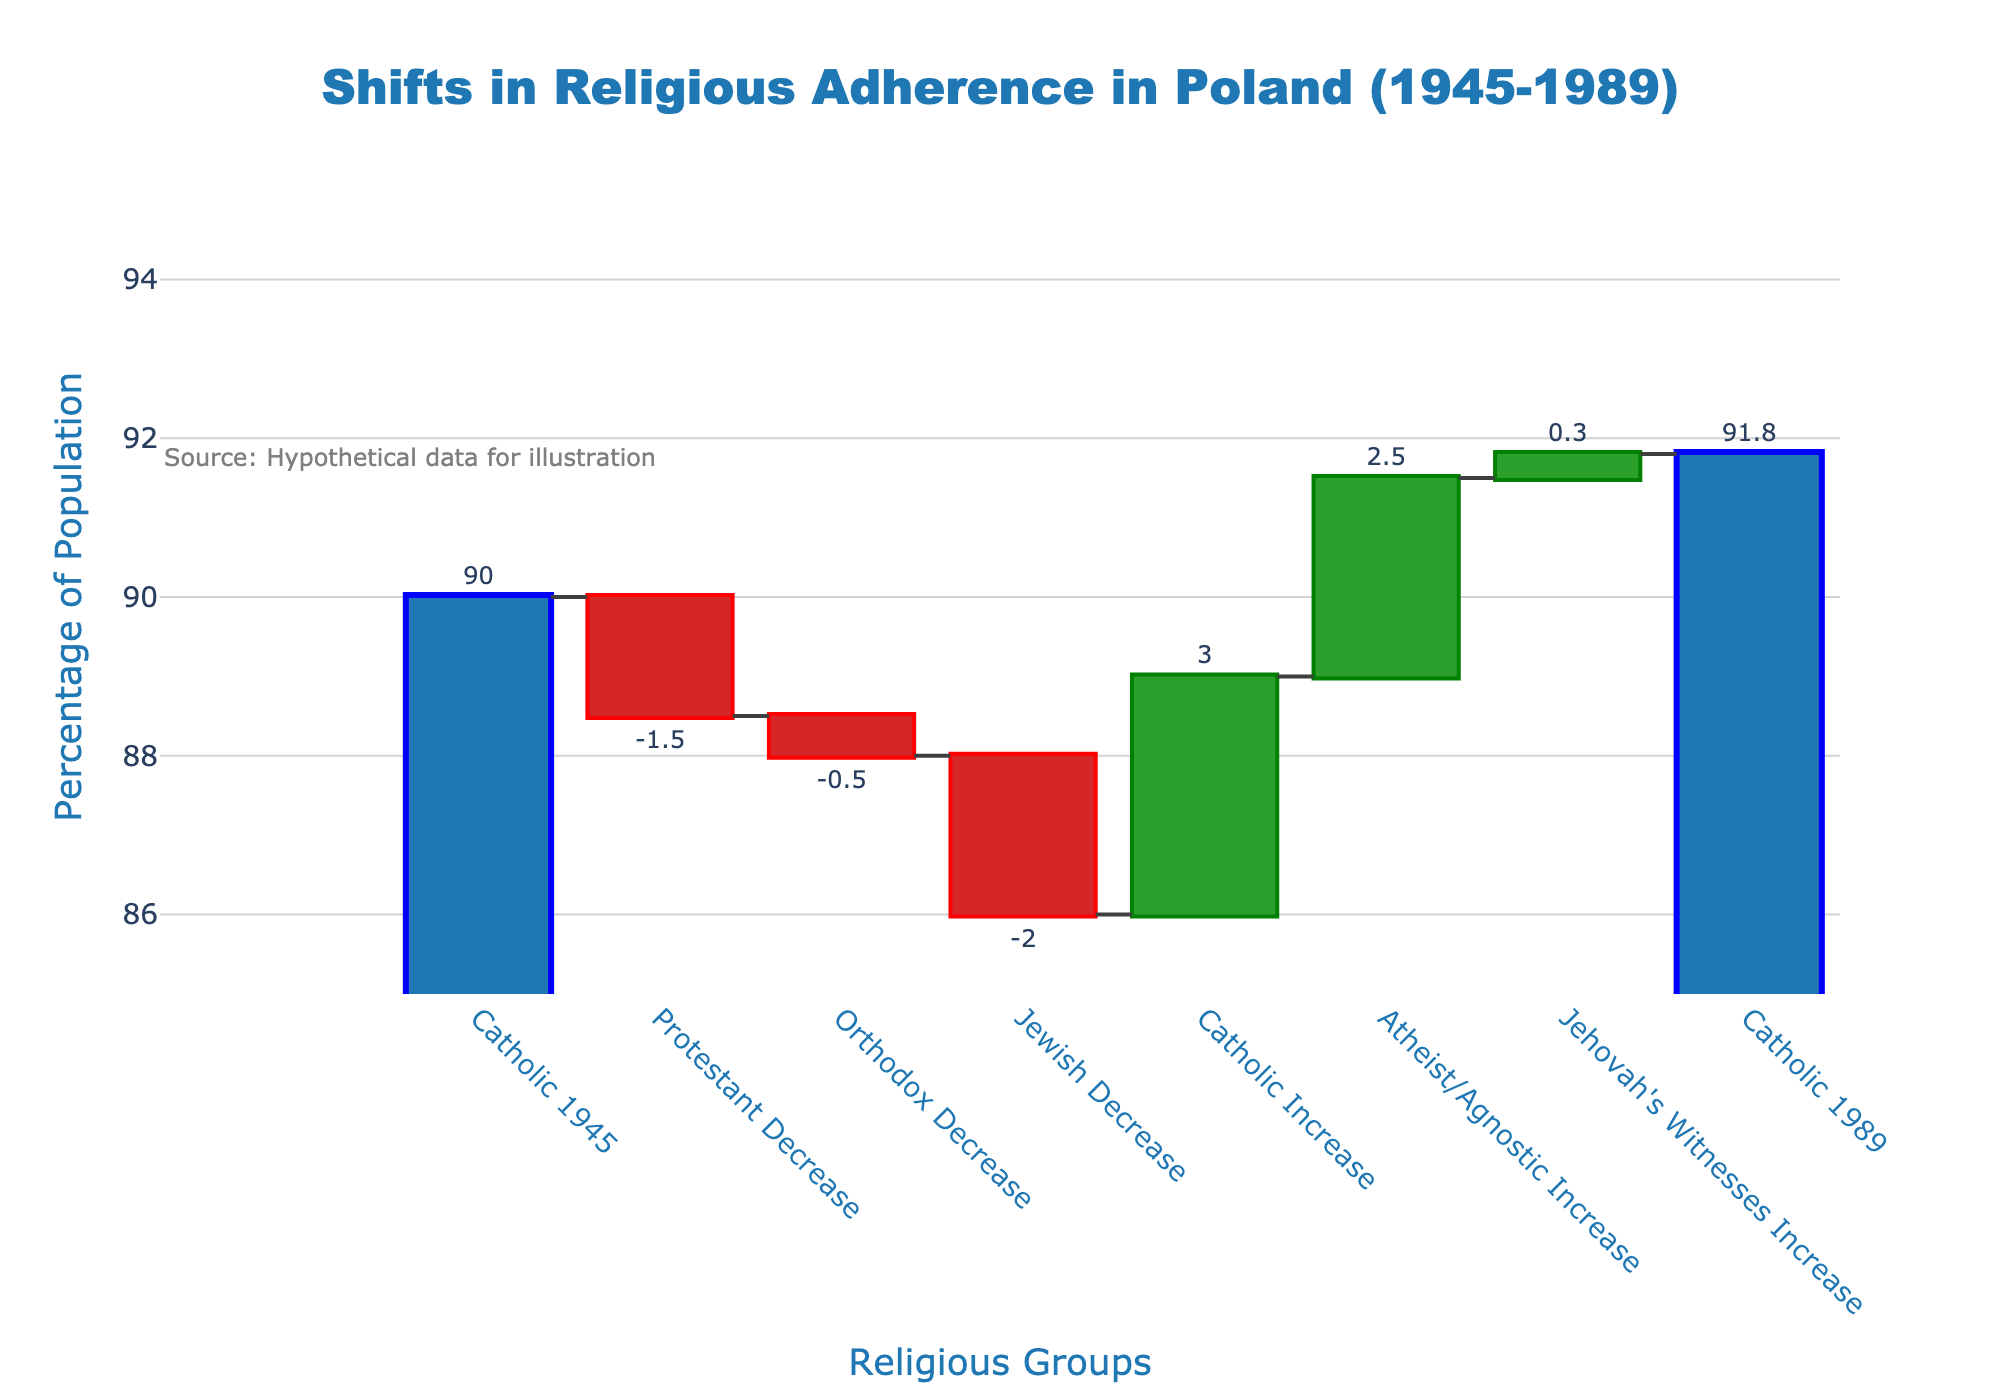How many categories are in the waterfall chart? The chart lists "Catholic 1945", "Protestant Decrease", "Orthodox Decrease", "Jewish Decrease", "Catholic Increase", "Atheist/Agnostic Increase", "Jehovah's Witnesses Increase", and "Catholic 1989" as categories. Count the total distinct categories mentioned.
Answer: 8 What is the percentage increase in "Atheist/Agnostic Increase"? Look at the "Atheist/Agnostic Increase" bar, which shows a value of 2.5%. This represents the percentage increase.
Answer: 2.5% How does the Catholic population change from 1945 to 1989? Start with the "Catholic 1945" value which is 90%, and then refer to "Catholic 1989" which is 91.8%. The difference is the change.
Answer: Increase by 1.8% Which religious group experienced the largest decrease in adherence? Compare the negative values ("Protestant Decrease", "Orthodox Decrease", "Jewish Decrease"), and find out that "Jewish Decrease" has the largest negative value of -2.0%.
Answer: Jewish What is the sum of the increases and decreases for all categories except "Catholic 1945" and "Catholic 1989"? Add the positive changes (3, 2.5, 0.3) and negative changes (-1.5, -0.5, -2). Sum = 3 + 2.5 + 0.3 - 1.5 - 0.5 - 2.
Answer: 1.8% How does the increase in "Catholic Increase" compare to the decrease in "Protestant Decrease"? The "Catholic Increase" is 3% and the "Protestant Decrease" is -1.5%. Compare their magnitudes.
Answer: Catholic Increase is greater by 1.5% In what range does the y-axis extend? The y-axis shows the percentage of the population, and it ranges from 85% to 95% based on the gridlines and range specified in the chart.
Answer: 85% to 95% What is the total population percentage accounted for by "Catholic 1989"? "Catholic 1989" is the final bar in the waterfall chart and its value is shown as 91.8%, representing the total percentage.
Answer: 91.8% Which category has the smallest increase? Evaluate the positive values for increases ("Catholic Increase", "Atheist/Agnostic Increase", "Jehovah's Witnesses Increase") and see that "Jehovah's Witnesses Increase" at 0.3% is the smallest.
Answer: Jehovah's Witnesses Increase 